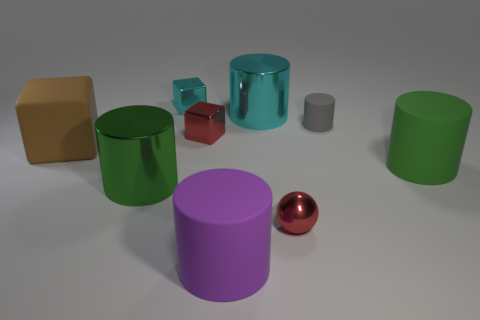Do the gray rubber thing and the red thing on the right side of the big purple object have the same shape?
Provide a succinct answer. No. What is the shape of the purple matte object that is right of the cyan metal block?
Offer a very short reply. Cylinder. Is the purple rubber thing the same shape as the tiny cyan object?
Offer a terse response. No. What is the size of the green rubber object that is the same shape as the green metallic thing?
Give a very brief answer. Large. There is a rubber cylinder behind the brown matte block; is it the same size as the cyan metallic cube?
Provide a short and direct response. Yes. What is the size of the object that is both on the right side of the red metal sphere and on the left side of the green matte cylinder?
Make the answer very short. Small. There is a small thing that is the same color as the small ball; what material is it?
Ensure brevity in your answer.  Metal. How many small blocks have the same color as the small metal ball?
Give a very brief answer. 1. Are there an equal number of small red balls on the left side of the large cyan object and small gray matte cylinders?
Keep it short and to the point. No. What is the color of the tiny cylinder?
Offer a very short reply. Gray. 